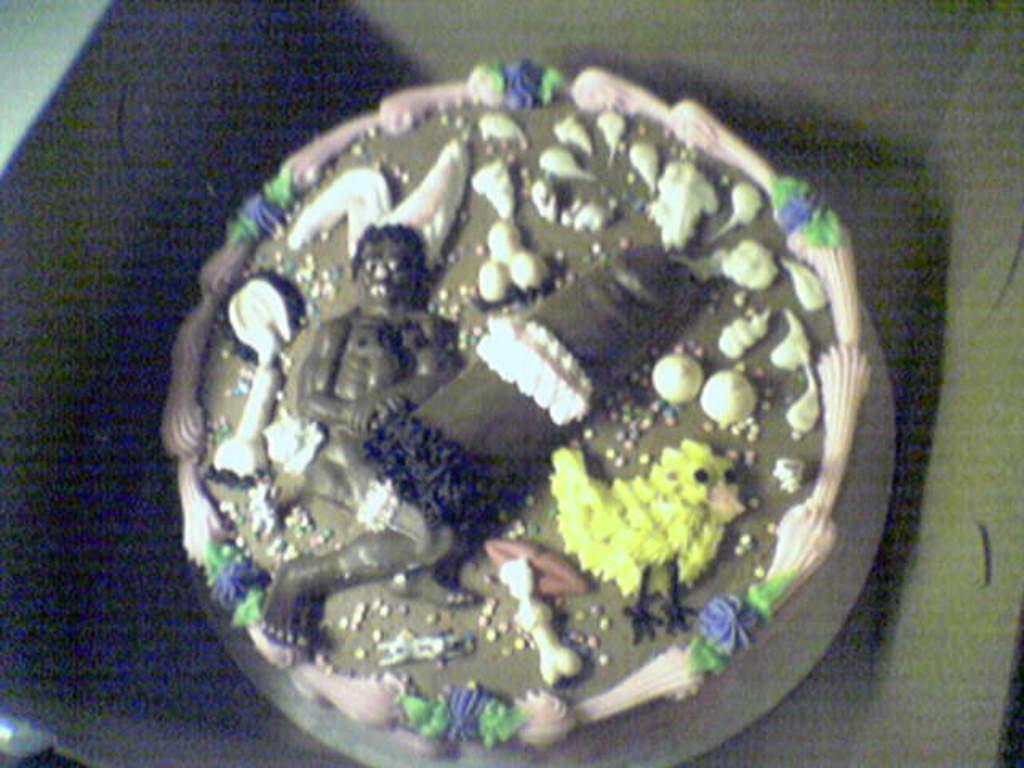Describe this image in one or two sentences. In this picture we can see a cake in the box. 